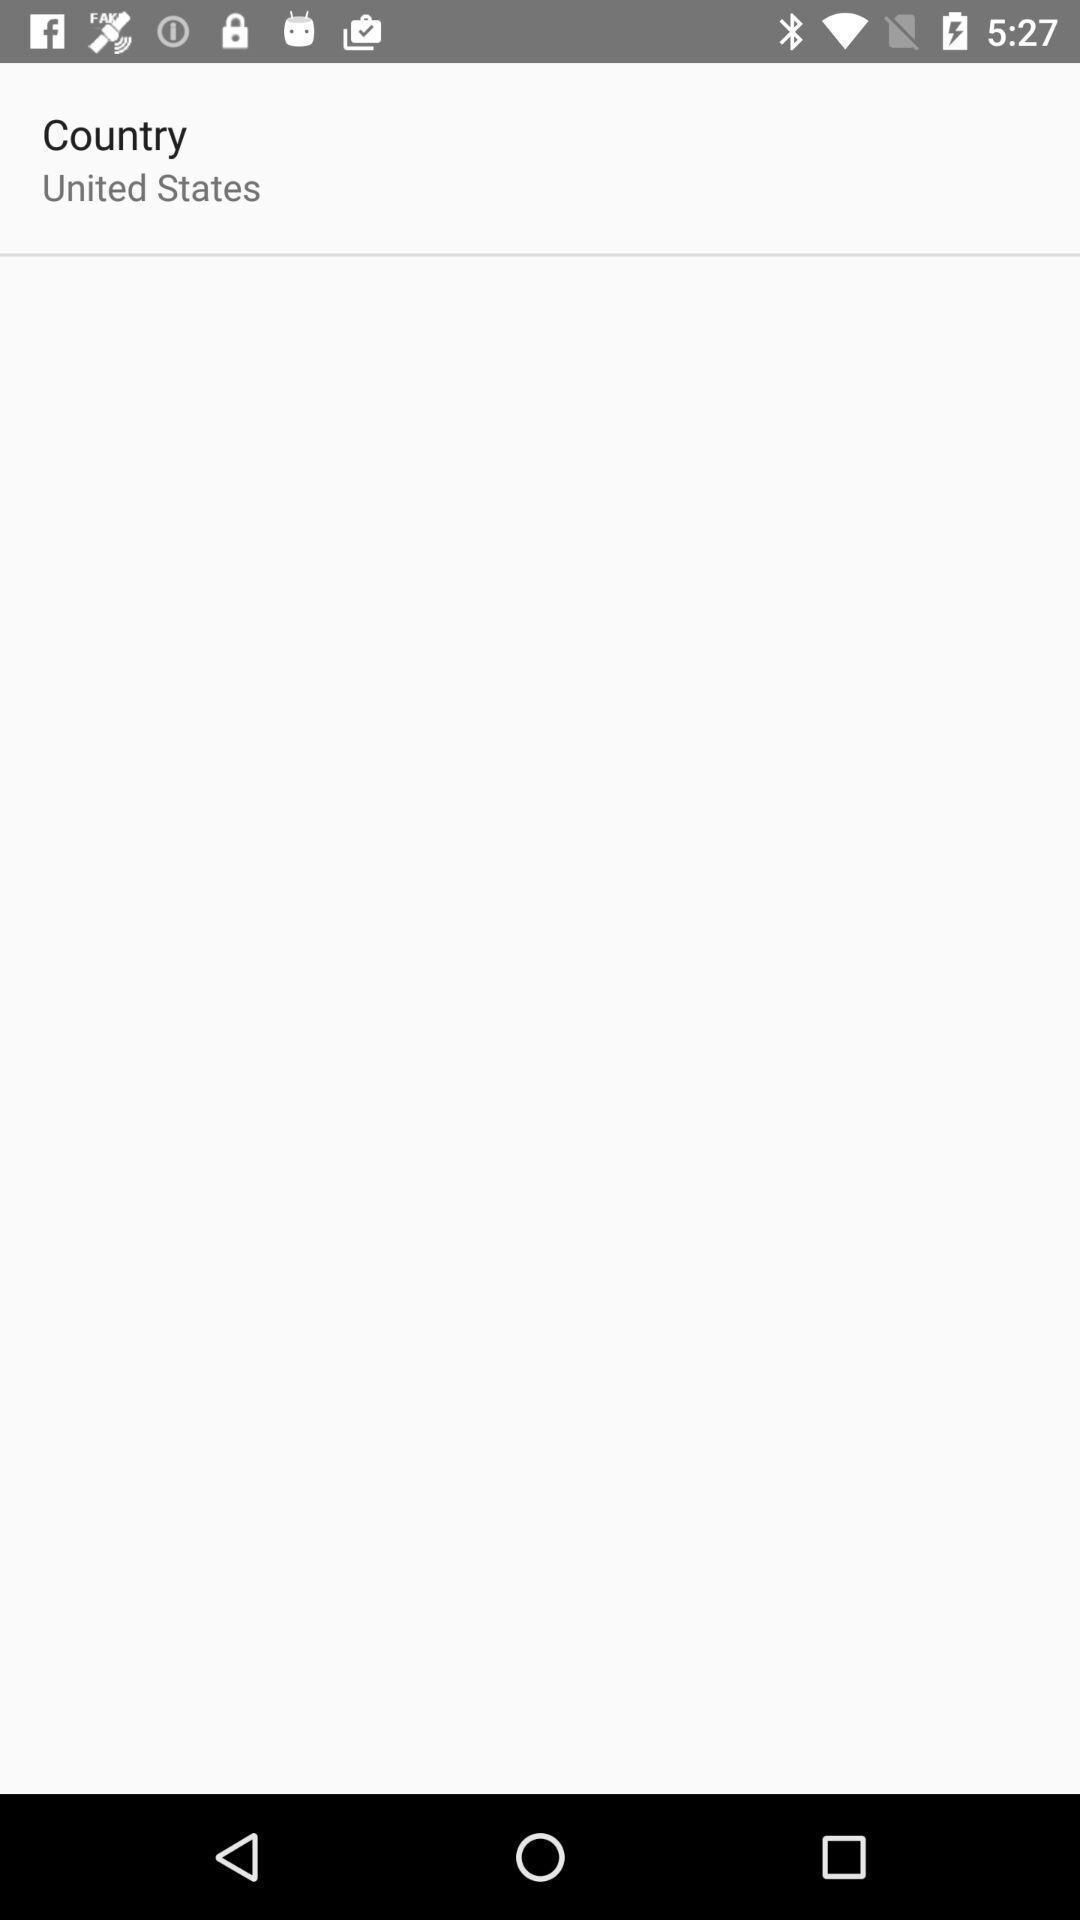Explain the elements present in this screenshot. Page showing an empty space showing a country. 